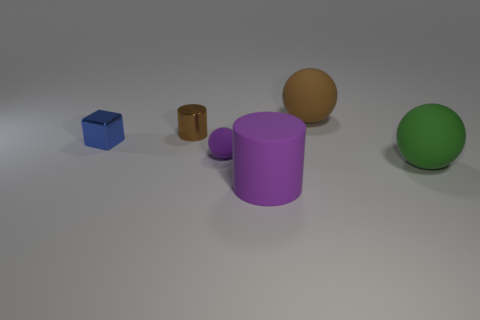Add 2 shiny blocks. How many objects exist? 8 Subtract all cylinders. How many objects are left? 4 Add 5 blue cylinders. How many blue cylinders exist? 5 Subtract 1 brown cylinders. How many objects are left? 5 Subtract all cylinders. Subtract all tiny blue matte balls. How many objects are left? 4 Add 2 large brown objects. How many large brown objects are left? 3 